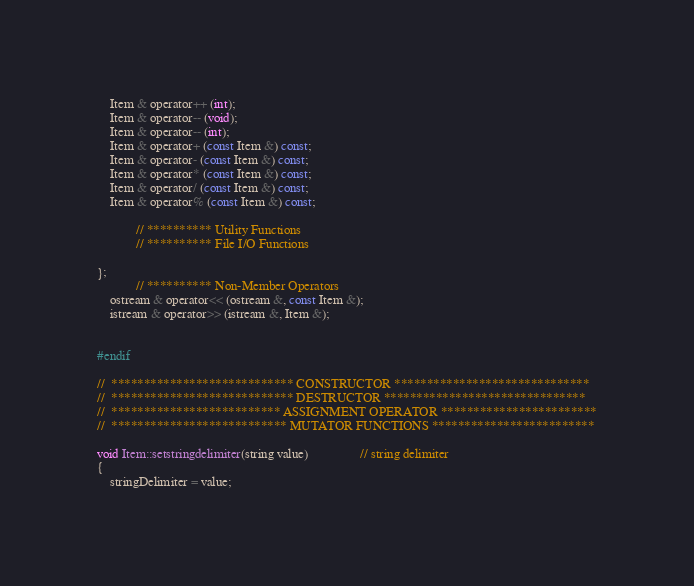<code> <loc_0><loc_0><loc_500><loc_500><_C_>	Item & operator++ (int);
	Item & operator-- (void);
	Item & operator-- (int);
	Item & operator+ (const Item &) const;
	Item & operator- (const Item &) const;
	Item & operator* (const Item &) const;
	Item & operator/ (const Item &) const;
	Item & operator% (const Item &) const;

			// ********** Utility Functions 
			// ********** File I/O Functions

};
			// ********** Non-Member Operators
	ostream & operator<< (ostream &, const Item &);
	istream & operator>> (istream &, Item &);


#endif

//  **************************** CONSTRUCTOR ******************************
//  **************************** DESTRUCTOR *******************************
//  ************************** ASSIGNMENT OPERATOR ************************
//  *************************** MUTATOR FUNCTIONS *************************

void Item::setstringdelimiter(string value)				// string delimiter
{
	stringDelimiter = value;</code> 